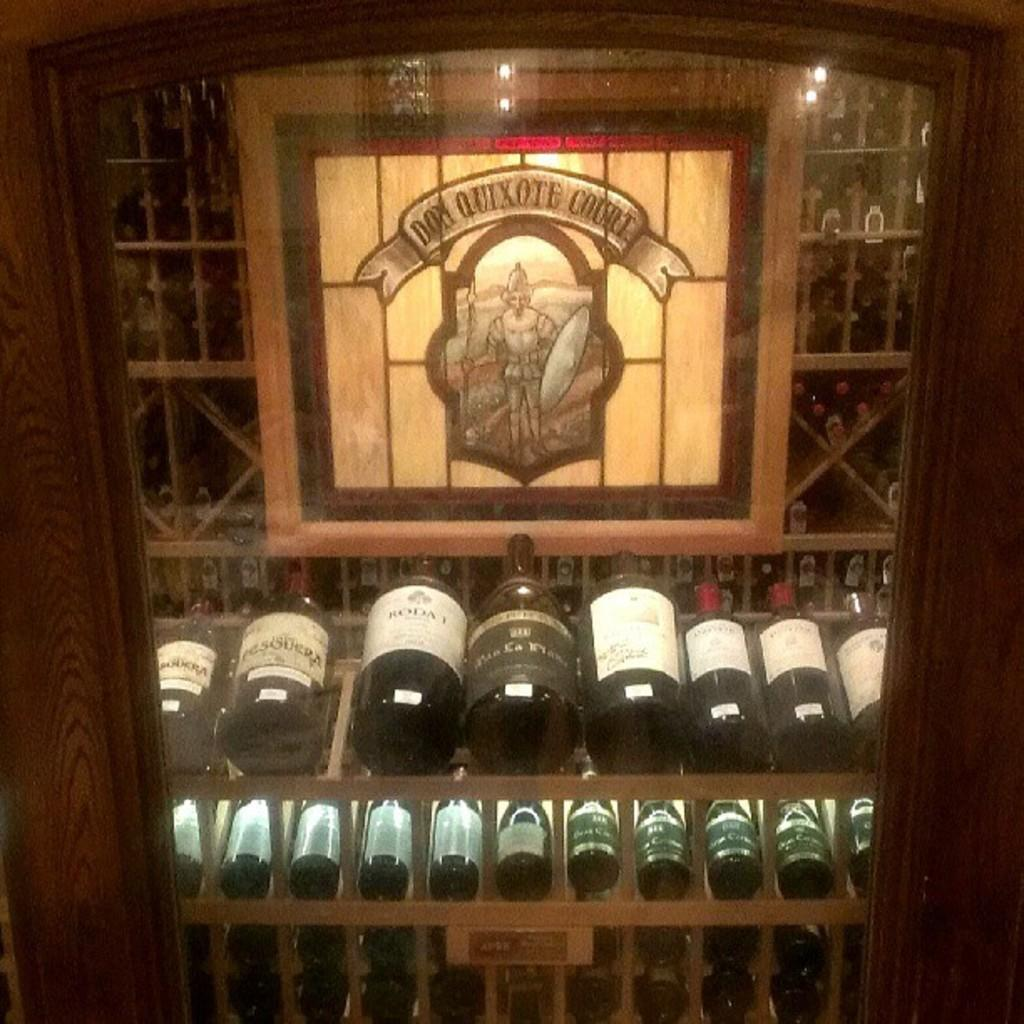What objects are present in the image? There are bottles in the image. How are the bottles arranged? The bottles are in racks. Can you describe any other objects in the image? There is a logo on an object behind the bottles, and there is a glass in front of the bottles. What type of alarm can be heard going off in the image? There is no alarm present in the image, and therefore no sound can be heard. 